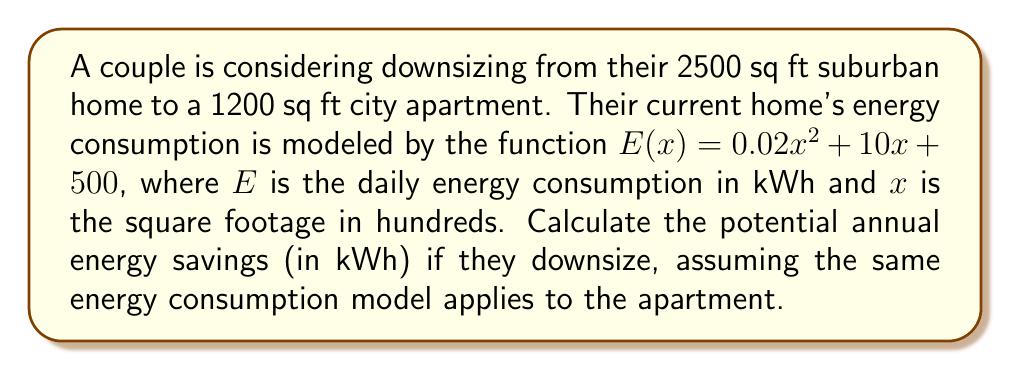Give your solution to this math problem. To solve this problem, we need to:
1. Set up integrals for both the current home and the potential apartment
2. Calculate the difference between these integrals
3. Multiply by 365 to get annual savings

Step 1: Set up integrals
For the current home (2500 sq ft = 25 hundred sq ft):
$$\int_0^{25} (0.02x^2 + 10x + 500) dx$$

For the potential apartment (1200 sq ft = 12 hundred sq ft):
$$\int_0^{12} (0.02x^2 + 10x + 500) dx$$

Step 2: Calculate the difference
Annual savings = 365 * (Current home integral - Potential apartment integral)

$$365 * \left(\int_0^{25} (0.02x^2 + 10x + 500) dx - \int_0^{12} (0.02x^2 + 10x + 500) dx\right)$$

Step 3: Evaluate the integrals
$$\int (0.02x^2 + 10x + 500) dx = \frac{0.02x^3}{3} + 5x^2 + 500x + C$$

For the current home:
$$\left[\frac{0.02(25)^3}{3} + 5(25)^2 + 500(25)\right] - \left[\frac{0.02(0)^3}{3} + 5(0)^2 + 500(0)\right] = 18,645.83$$

For the potential apartment:
$$\left[\frac{0.02(12)^3}{3} + 5(12)^2 + 500(12)\right] - \left[\frac{0.02(0)^3}{3} + 5(0)^2 + 500(0)\right] = 7,888$$

Step 4: Calculate the difference and multiply by 365
Annual savings = 365 * (18,645.83 - 7,888) = 3,926,612.95 kWh
Answer: 3,926,613 kWh 